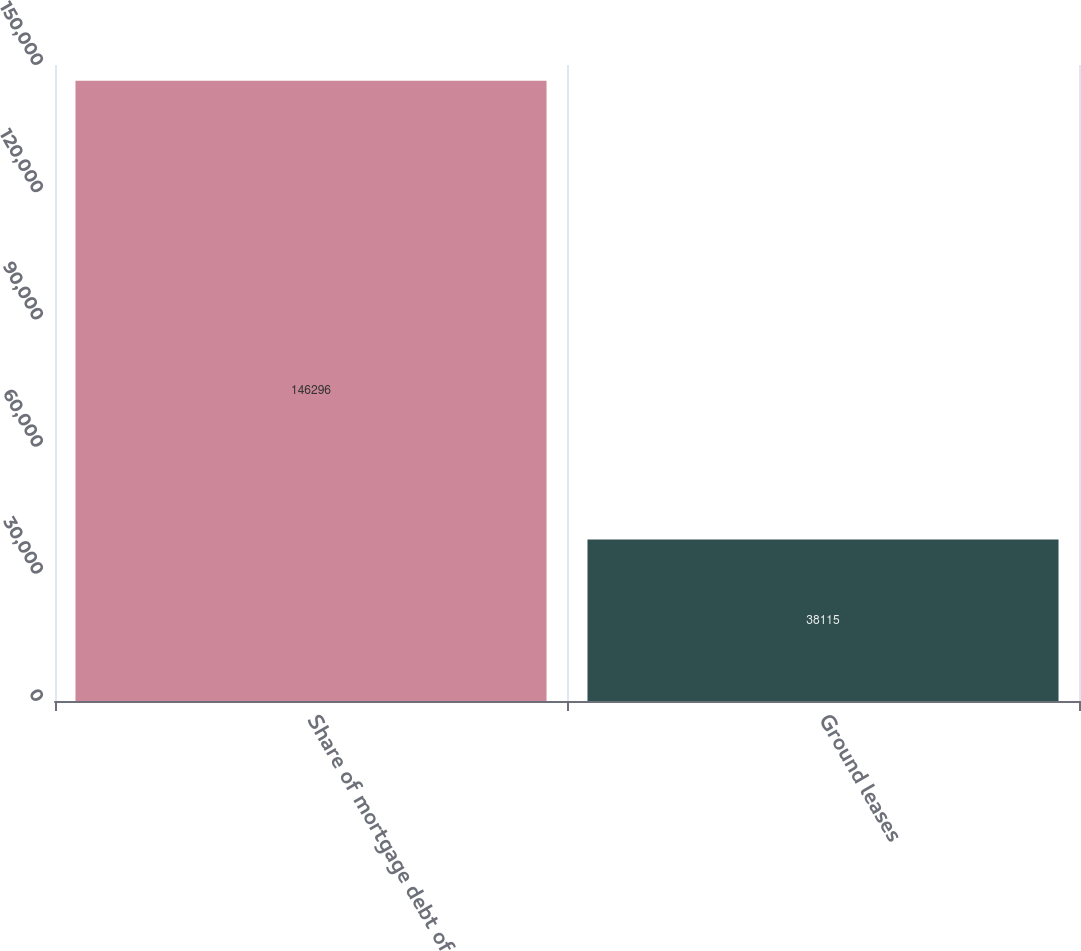Convert chart to OTSL. <chart><loc_0><loc_0><loc_500><loc_500><bar_chart><fcel>Share of mortgage debt of<fcel>Ground leases<nl><fcel>146296<fcel>38115<nl></chart> 